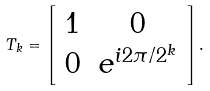<formula> <loc_0><loc_0><loc_500><loc_500>T _ { k } = \left [ \begin{array} { c c } 1 & 0 \\ 0 & e ^ { i 2 \pi / 2 ^ { k } } \end{array} \right ] .</formula> 